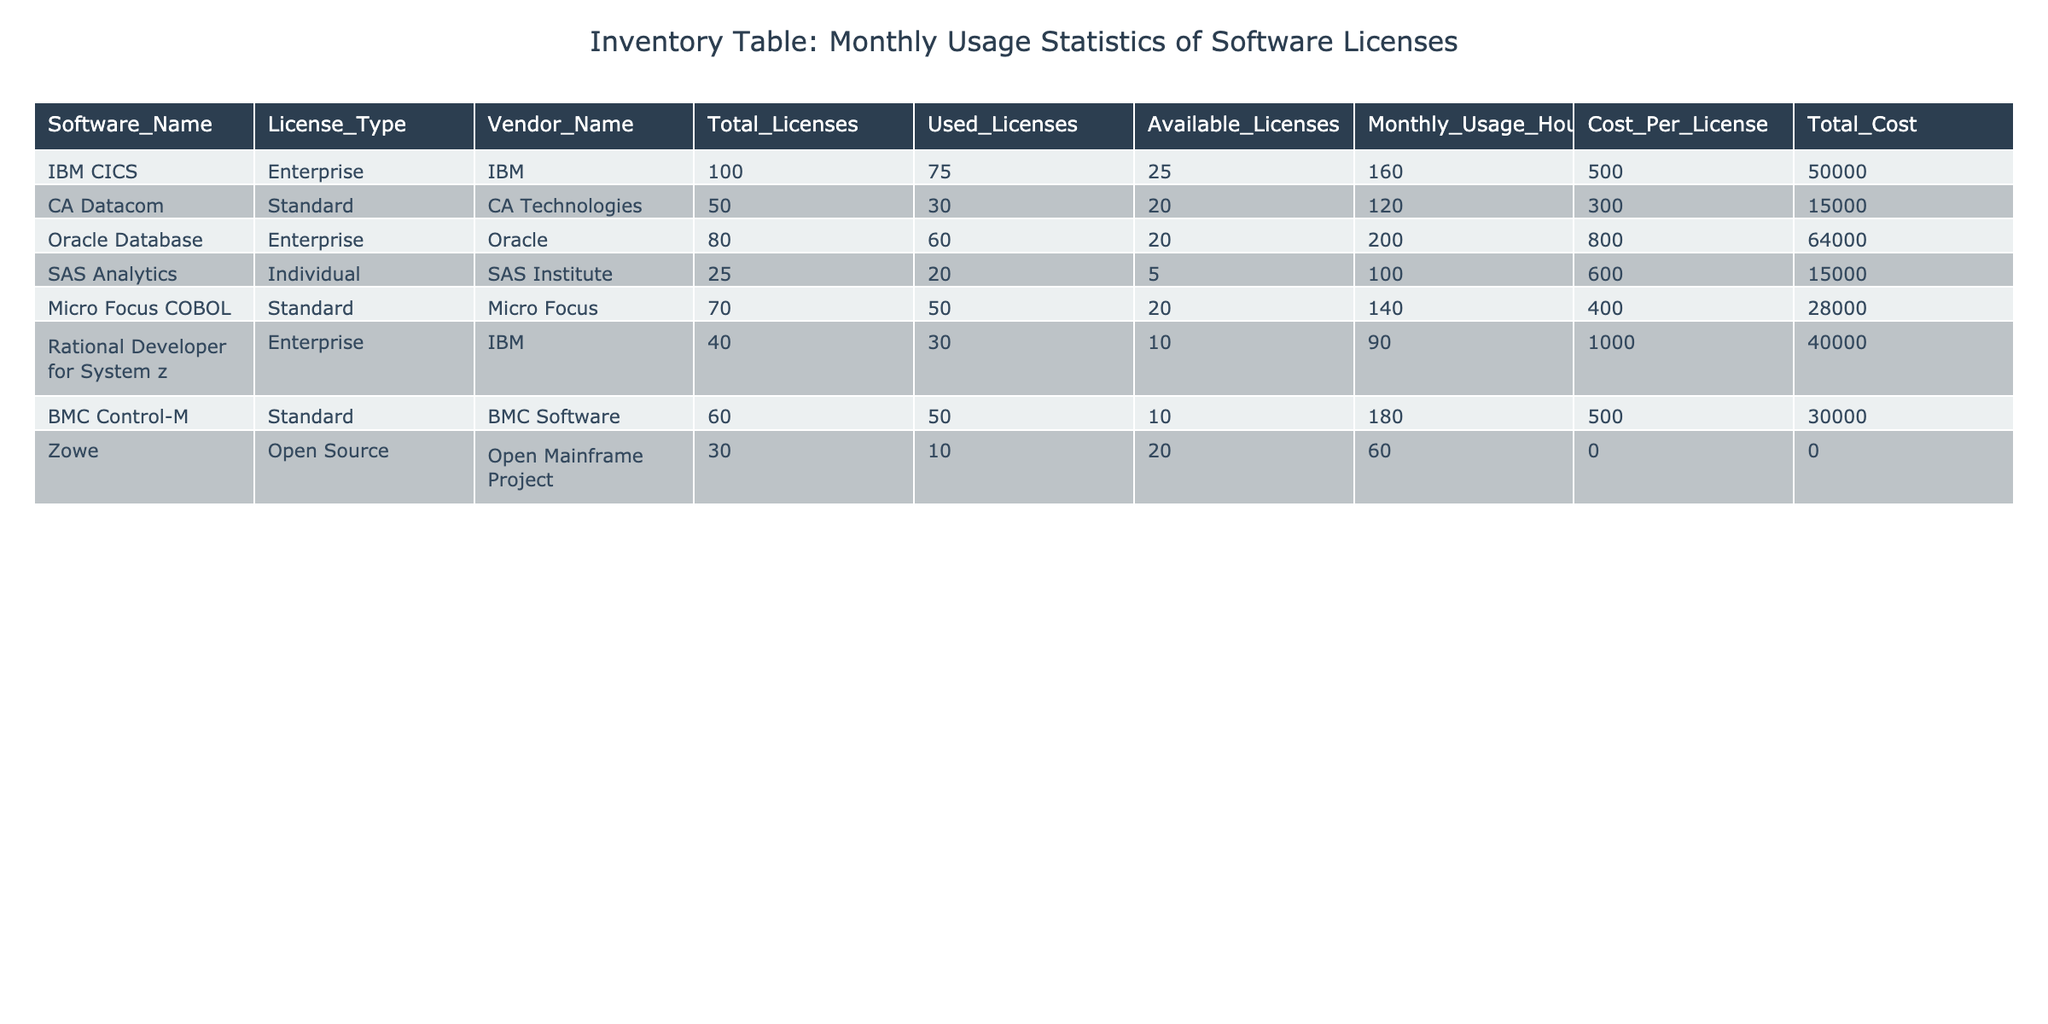What is the total number of licenses for Oracle Database? The table shows the row for Oracle Database, where the value under the Total Licenses column reads 80.
Answer: 80 How many licenses are available for SAS Analytics? In the row for SAS Analytics, the Available Licenses column indicates there are 5 licenses available.
Answer: 5 What is the combined total cost of all software licenses in the table? To find the total cost, we sum the values in the Total Cost column: 50000 + 15000 + 64000 + 15000 + 28000 + 40000 + 30000 + 0 = 193000.
Answer: 193000 Are there more used licenses than available licenses for Micro Focus COBOL? In the row for Micro Focus COBOL, there are 50 used licenses and 20 available licenses, so it is true that there are more used licenses.
Answer: Yes Which software has the highest monthly usage hours? By comparing the Monthly Usage Hours column, BMC Control-M has the highest usage with 180 hours, more than any other software listed.
Answer: BMC Control-M What is the average number of licenses used across all software? To obtain the average, add the used licenses: 75 + 30 + 60 + 20 + 50 + 30 + 50 + 10 = 325, then divide by the number of software (8), resulting in an average of 40.625.
Answer: 40.625 Which software has the lowest cost per license? By examining the Cost Per License column, Zowe has a cost of 0, which is the lowest compared to other software.
Answer: Zowe Is the number of available licenses for CA Datacom greater than that for IBM CICS? For CA Datacom, there are 20 available licenses, while for IBM CICS, there are 25 available licenses. Therefore, it is false that CA Datacom has more available licenses.
Answer: No If SAS Analytics and Micro Focus COBOL are combined, how many total licenses do they have? For SAS Analytics, there are 25 total licenses, and for Micro Focus COBOL, there are 70 total licenses. Adding these together gives us 25 + 70 = 95 total licenses.
Answer: 95 